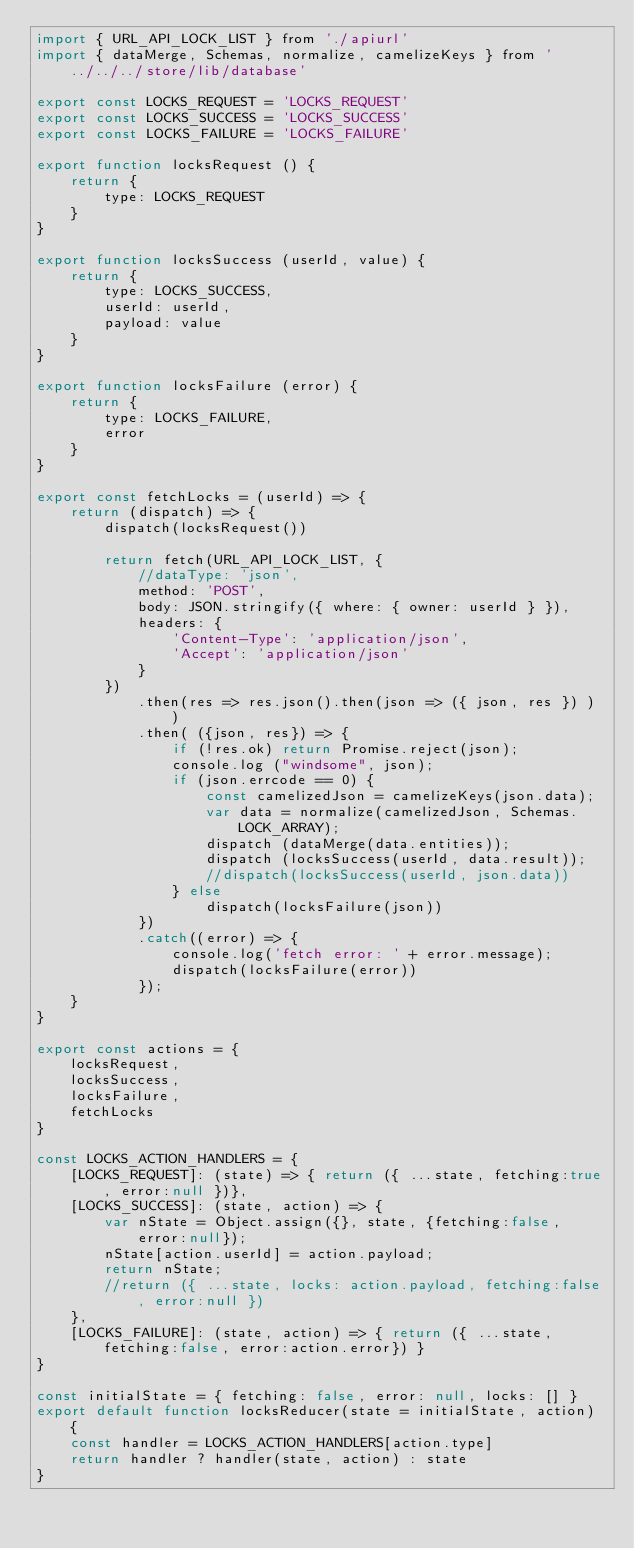<code> <loc_0><loc_0><loc_500><loc_500><_JavaScript_>import { URL_API_LOCK_LIST } from './apiurl'
import { dataMerge, Schemas, normalize, camelizeKeys } from '../../../store/lib/database'

export const LOCKS_REQUEST = 'LOCKS_REQUEST'
export const LOCKS_SUCCESS = 'LOCKS_SUCCESS'
export const LOCKS_FAILURE = 'LOCKS_FAILURE'

export function locksRequest () {
    return {
        type: LOCKS_REQUEST
    }
}

export function locksSuccess (userId, value) {
    return {
        type: LOCKS_SUCCESS,
        userId: userId,
        payload: value
    }
}

export function locksFailure (error) {
    return {
        type: LOCKS_FAILURE,
        error
    }
}

export const fetchLocks = (userId) => {
    return (dispatch) => {
        dispatch(locksRequest())
        
        return fetch(URL_API_LOCK_LIST, {
            //dataType: 'json',
            method: 'POST',
            body: JSON.stringify({ where: { owner: userId } }),
            headers: {
                'Content-Type': 'application/json',
                'Accept': 'application/json'
            }
        })
            .then(res => res.json().then(json => ({ json, res }) ) )
            .then( ({json, res}) => {
                if (!res.ok) return Promise.reject(json);
                console.log ("windsome", json);
                if (json.errcode == 0) {
                    const camelizedJson = camelizeKeys(json.data); 
                    var data = normalize(camelizedJson, Schemas.LOCK_ARRAY);
                    dispatch (dataMerge(data.entities));
                    dispatch (locksSuccess(userId, data.result));
                    //dispatch(locksSuccess(userId, json.data))
                } else
                    dispatch(locksFailure(json))
            })
            .catch((error) => {
                console.log('fetch error: ' + error.message);
                dispatch(locksFailure(error))
            });
    }
}

export const actions = {
    locksRequest,
    locksSuccess,
    locksFailure,
    fetchLocks
}

const LOCKS_ACTION_HANDLERS = {
    [LOCKS_REQUEST]: (state) => { return ({ ...state, fetching:true, error:null })},
    [LOCKS_SUCCESS]: (state, action) => { 
        var nState = Object.assign({}, state, {fetching:false, error:null});
        nState[action.userId] = action.payload;
        return nState;
        //return ({ ...state, locks: action.payload, fetching:false, error:null })
    },
    [LOCKS_FAILURE]: (state, action) => { return ({ ...state, fetching:false, error:action.error}) }
}

const initialState = { fetching: false, error: null, locks: [] }
export default function locksReducer(state = initialState, action) {
    const handler = LOCKS_ACTION_HANDLERS[action.type]
    return handler ? handler(state, action) : state
}
</code> 